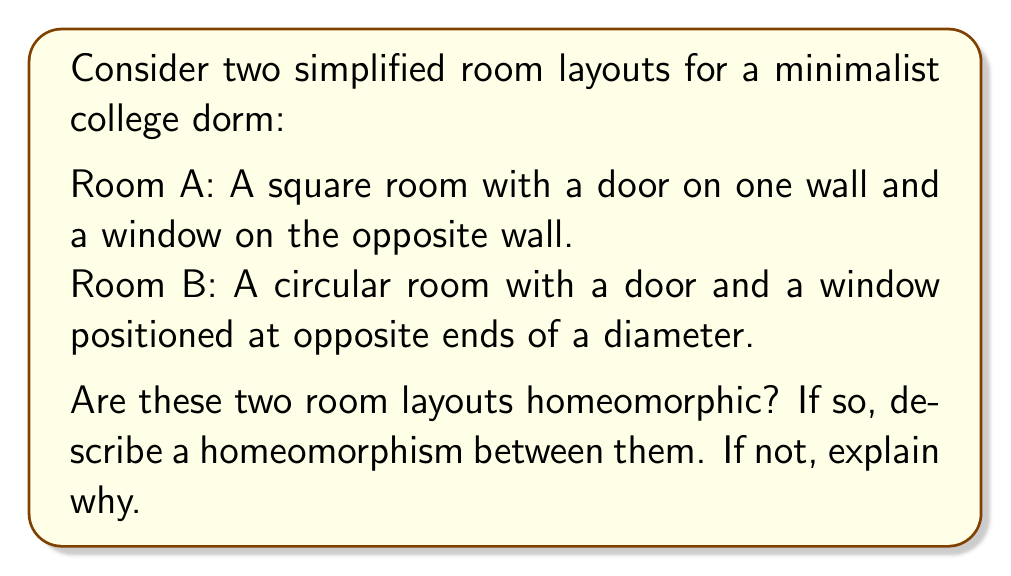Give your solution to this math problem. To determine if the two room layouts are homeomorphic, we need to consider the topological properties of each space and whether there exists a continuous bijective function with a continuous inverse between them.

1. Topological properties:
   Both rooms are two-dimensional surfaces with boundaries. The key features to consider are:
   - The presence of a boundary (walls)
   - The number and arrangement of "holes" (door and window)

2. Analysis:
   a) Both rooms have a continuous boundary (walls).
   b) Both rooms have exactly two "holes" (door and window) that are distinct and separated.
   c) The shape difference (square vs. circle) is not relevant for topological equivalence.

3. Constructing a homeomorphism:
   We can construct a homeomorphism $f: A \to B$ as follows:
   
   a) Map the corners of the square to four equally spaced points on the circle.
   b) Map each wall of the square to the corresponding arc of the circle.
   c) Map the door and window of Room A to the door and window of Room B, respectively.
   d) Continuously deform the interior points of Room A to fill the interior of Room B.

4. Properties of the homeomorphism:
   - $f$ is bijective: Each point in Room A maps to a unique point in Room B, and vice versa.
   - $f$ is continuous: nearby points in Room A map to nearby points in Room B.
   - $f^{-1}$ exists and is continuous: The inverse mapping from Room B to Room A can be constructed similarly.

5. Visualization:
   [asy]
   import geometry;

   // Room A (Square)
   draw(unitsquare, blue);
   draw((0.3,0)--(0.7,0), red);  // Door
   draw((0.3,1)--(0.7,1), green);  // Window

   // Room B (Circle)
   draw(shift(3,0.5)*unitcircle, blue);
   draw(shift(3,0.5)*((1,0)--(1,0)), red);  // Door
   draw(shift(3,0.5)*((-1,0)--(-1,0)), green);  // Window

   // Arrows indicating homeomorphism
   draw((1.2,0.5)--(2.3,0.5), arrow=Arrow(TeXHead));
   [/asy]

Therefore, the two room layouts are indeed homeomorphic.
Answer: Yes, the two room layouts are homeomorphic. A homeomorphism can be constructed by mapping the square boundary of Room A to the circular boundary of Room B, while preserving the relative positions of the door and window. The interior points can be continuously deformed to complete the homeomorphism. 